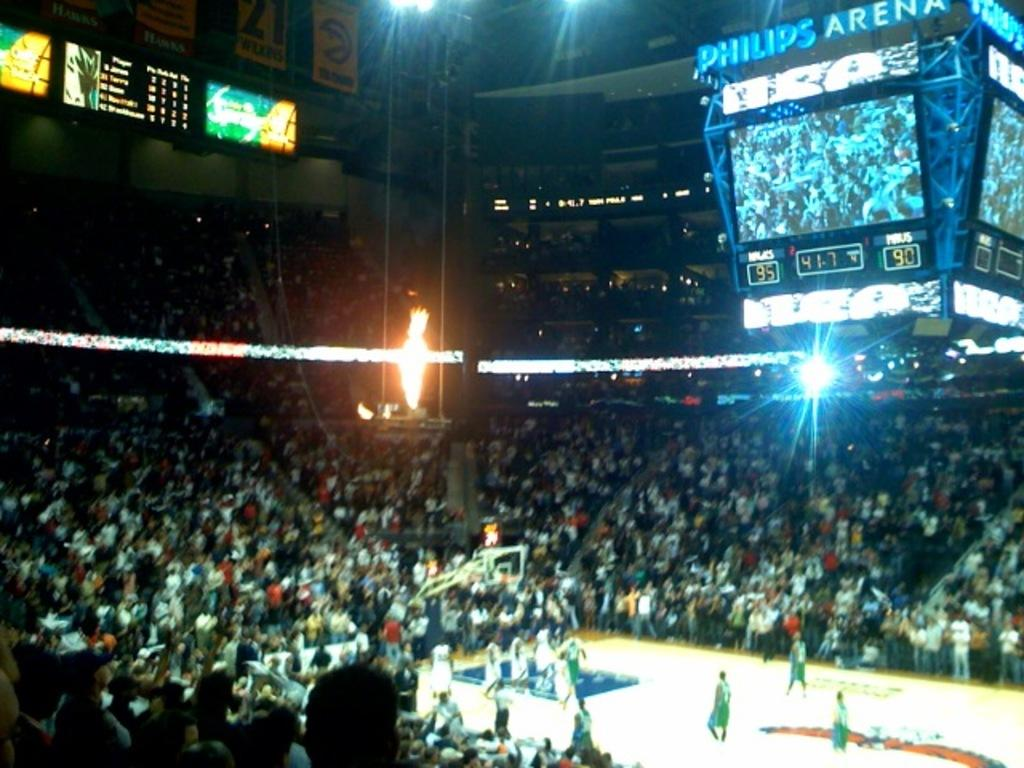Provide a one-sentence caption for the provided image. a sports game going on at the Philips Arena. 